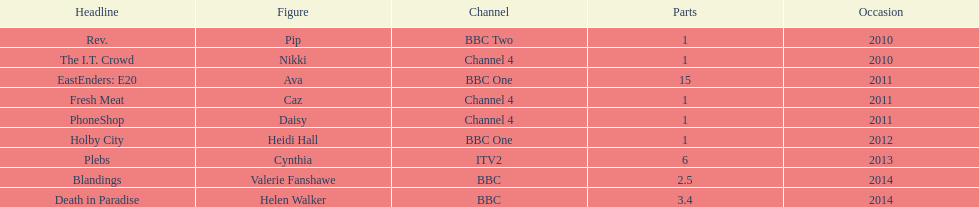Blandings and death in paradise both aired on which broadcaster? BBC. 